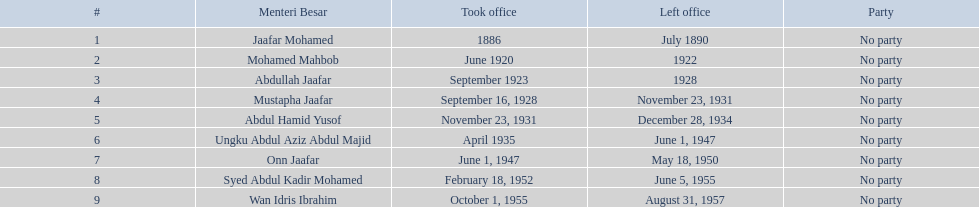Which menteri besars started their appointments in the 1920s? Mohamed Mahbob, Abdullah Jaafar, Mustapha Jaafar. From this group, who served for a mere two years? Mohamed Mahbob. 